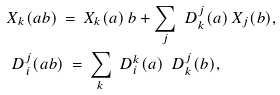<formula> <loc_0><loc_0><loc_500><loc_500>& X _ { k } ( a b ) \, = \, X _ { k } ( a ) \, b + \sum _ { j } \ D ^ { j } _ { k } ( a ) \, X _ { j } ( b ) , \\ & \ D _ { i } ^ { j } ( a b ) \, = \, \sum _ { k } \ D _ { i } ^ { k } ( a ) \, \ D _ { k } ^ { j } ( b ) ,</formula> 